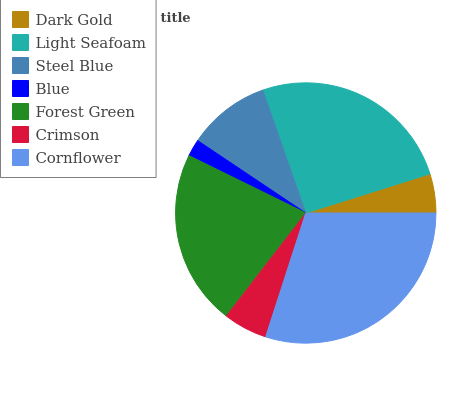Is Blue the minimum?
Answer yes or no. Yes. Is Cornflower the maximum?
Answer yes or no. Yes. Is Light Seafoam the minimum?
Answer yes or no. No. Is Light Seafoam the maximum?
Answer yes or no. No. Is Light Seafoam greater than Dark Gold?
Answer yes or no. Yes. Is Dark Gold less than Light Seafoam?
Answer yes or no. Yes. Is Dark Gold greater than Light Seafoam?
Answer yes or no. No. Is Light Seafoam less than Dark Gold?
Answer yes or no. No. Is Steel Blue the high median?
Answer yes or no. Yes. Is Steel Blue the low median?
Answer yes or no. Yes. Is Crimson the high median?
Answer yes or no. No. Is Blue the low median?
Answer yes or no. No. 